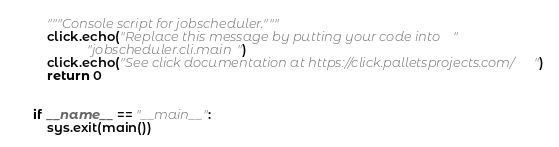Convert code to text. <code><loc_0><loc_0><loc_500><loc_500><_Python_>    """Console script for jobscheduler."""
    click.echo("Replace this message by putting your code into "
               "jobscheduler.cli.main")
    click.echo("See click documentation at https://click.palletsprojects.com/")
    return 0


if __name__ == "__main__":
    sys.exit(main())
</code> 